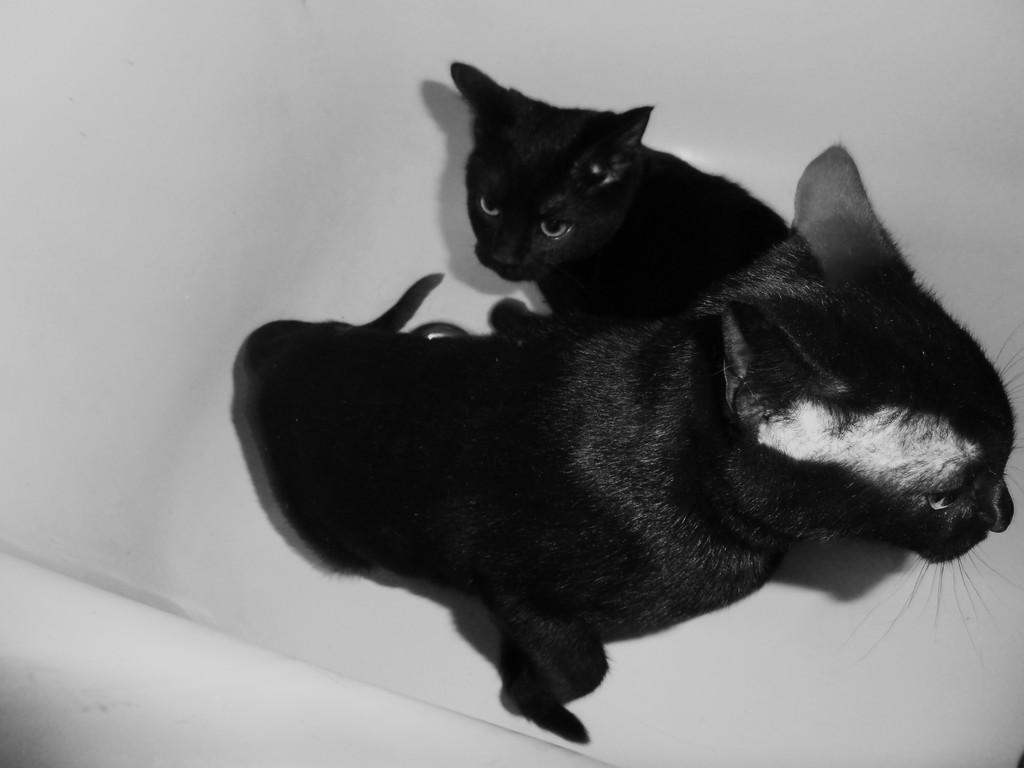How many cats are present in the image? There are two cats in the image. Where are the cats located in the image? The cats are in the center of the image. What type of structure can be seen behind the cats in the image? There is no structure visible behind the cats in the image; it only features the two cats. Are the cats sisters in the image? There is no information provided about the relationship between the cats, so we cannot determine if they are sisters. 